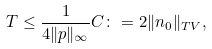Convert formula to latex. <formula><loc_0><loc_0><loc_500><loc_500>T \leq \frac { 1 } { 4 \| p \| _ { \infty } } C \colon = 2 \| n _ { 0 } \| _ { T V } ,</formula> 